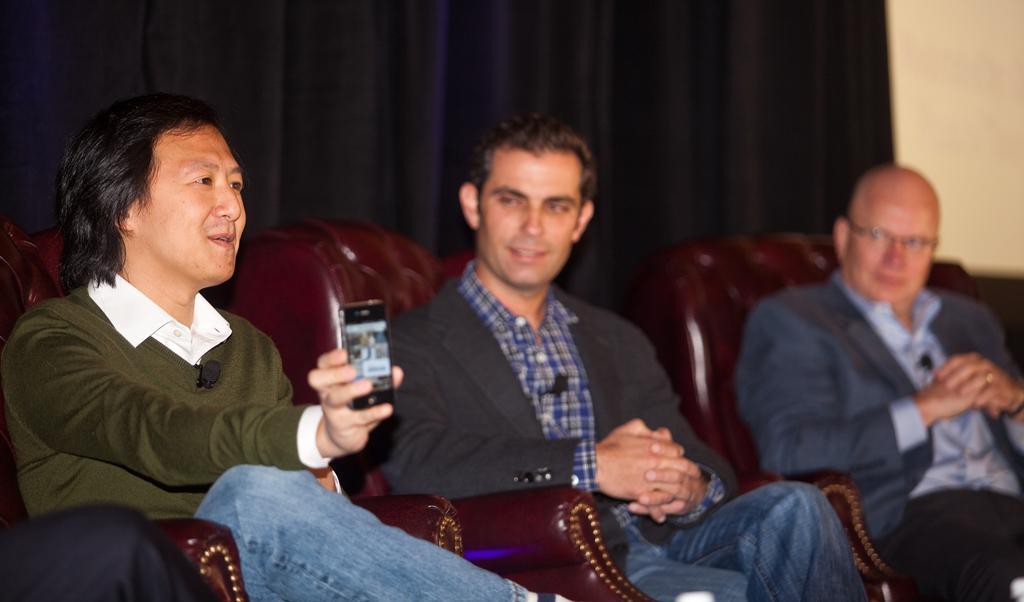Can you describe this image briefly? This shows that there are three men sitting in their respective sofas. One man is showing a mobile to someone. Two of them were staring at the third man. In the background there is a curtain and a wall here. 